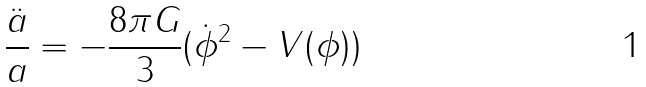<formula> <loc_0><loc_0><loc_500><loc_500>\frac { \ddot { a } } { a } = - \frac { 8 \pi G } { 3 } ( \dot { \phi } ^ { 2 } - V ( \phi ) )</formula> 